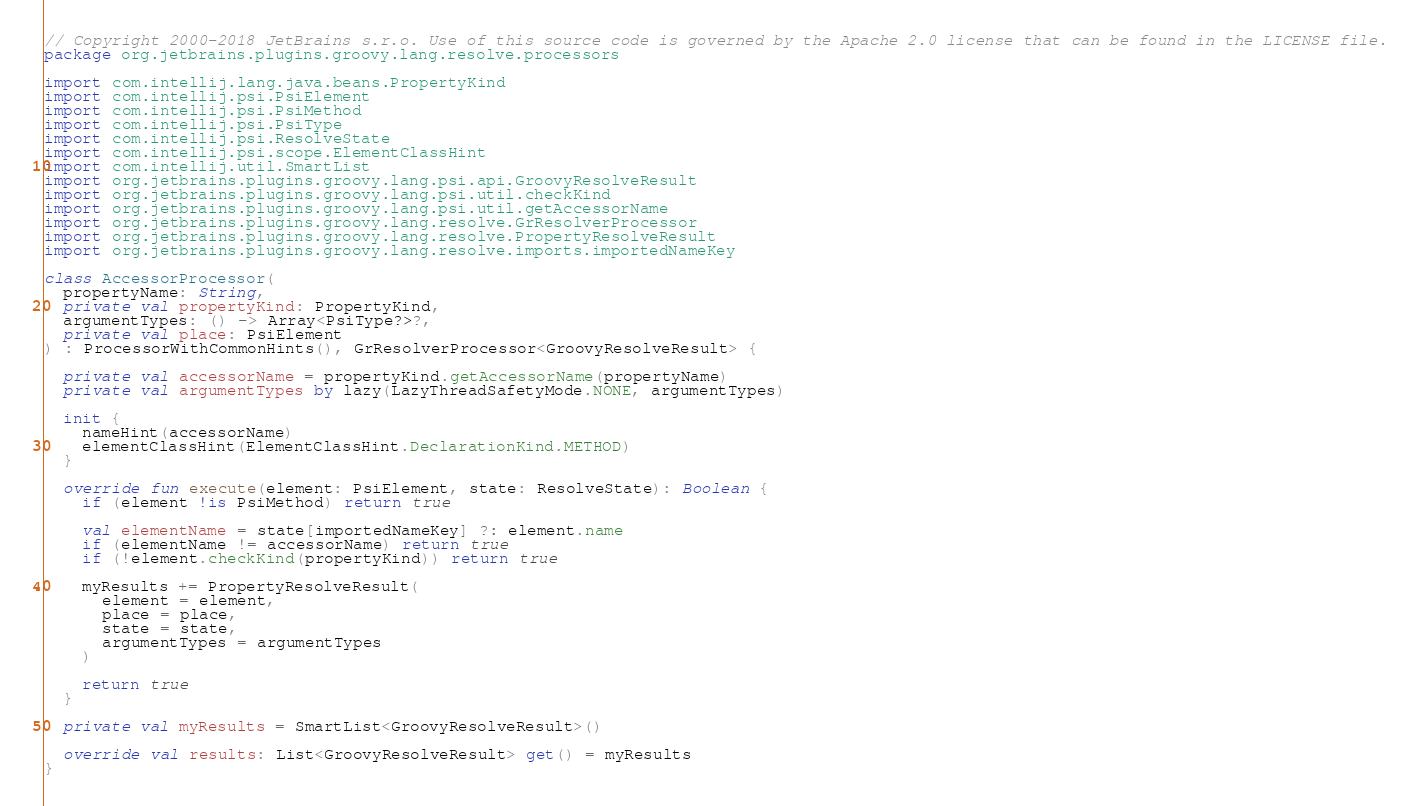Convert code to text. <code><loc_0><loc_0><loc_500><loc_500><_Kotlin_>// Copyright 2000-2018 JetBrains s.r.o. Use of this source code is governed by the Apache 2.0 license that can be found in the LICENSE file.
package org.jetbrains.plugins.groovy.lang.resolve.processors

import com.intellij.lang.java.beans.PropertyKind
import com.intellij.psi.PsiElement
import com.intellij.psi.PsiMethod
import com.intellij.psi.PsiType
import com.intellij.psi.ResolveState
import com.intellij.psi.scope.ElementClassHint
import com.intellij.util.SmartList
import org.jetbrains.plugins.groovy.lang.psi.api.GroovyResolveResult
import org.jetbrains.plugins.groovy.lang.psi.util.checkKind
import org.jetbrains.plugins.groovy.lang.psi.util.getAccessorName
import org.jetbrains.plugins.groovy.lang.resolve.GrResolverProcessor
import org.jetbrains.plugins.groovy.lang.resolve.PropertyResolveResult
import org.jetbrains.plugins.groovy.lang.resolve.imports.importedNameKey

class AccessorProcessor(
  propertyName: String,
  private val propertyKind: PropertyKind,
  argumentTypes: () -> Array<PsiType?>?,
  private val place: PsiElement
) : ProcessorWithCommonHints(), GrResolverProcessor<GroovyResolveResult> {

  private val accessorName = propertyKind.getAccessorName(propertyName)
  private val argumentTypes by lazy(LazyThreadSafetyMode.NONE, argumentTypes)

  init {
    nameHint(accessorName)
    elementClassHint(ElementClassHint.DeclarationKind.METHOD)
  }

  override fun execute(element: PsiElement, state: ResolveState): Boolean {
    if (element !is PsiMethod) return true

    val elementName = state[importedNameKey] ?: element.name
    if (elementName != accessorName) return true
    if (!element.checkKind(propertyKind)) return true

    myResults += PropertyResolveResult(
      element = element,
      place = place,
      state = state,
      argumentTypes = argumentTypes
    )

    return true
  }

  private val myResults = SmartList<GroovyResolveResult>()

  override val results: List<GroovyResolveResult> get() = myResults
}
</code> 